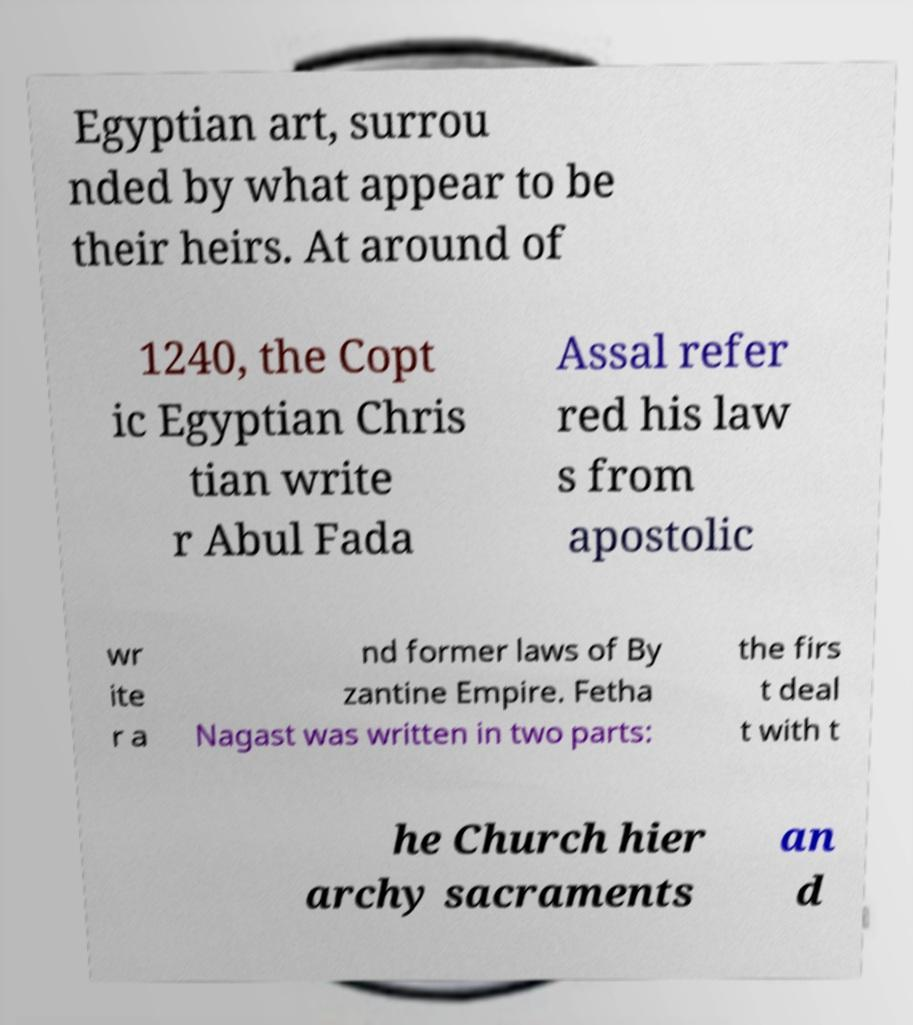Please read and relay the text visible in this image. What does it say? Egyptian art, surrou nded by what appear to be their heirs. At around of 1240, the Copt ic Egyptian Chris tian write r Abul Fada Assal refer red his law s from apostolic wr ite r a nd former laws of By zantine Empire. Fetha Nagast was written in two parts: the firs t deal t with t he Church hier archy sacraments an d 